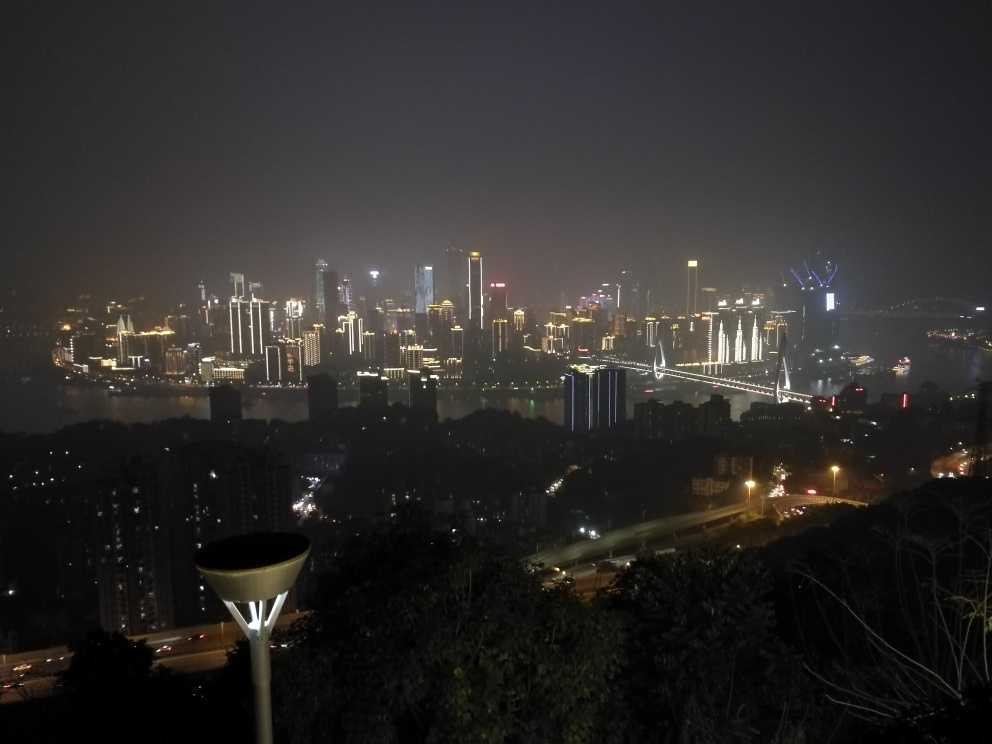Is the main subject very clear?
A. No
B. Yes
Answer with the option's letter from the given choices directly.
 A. 